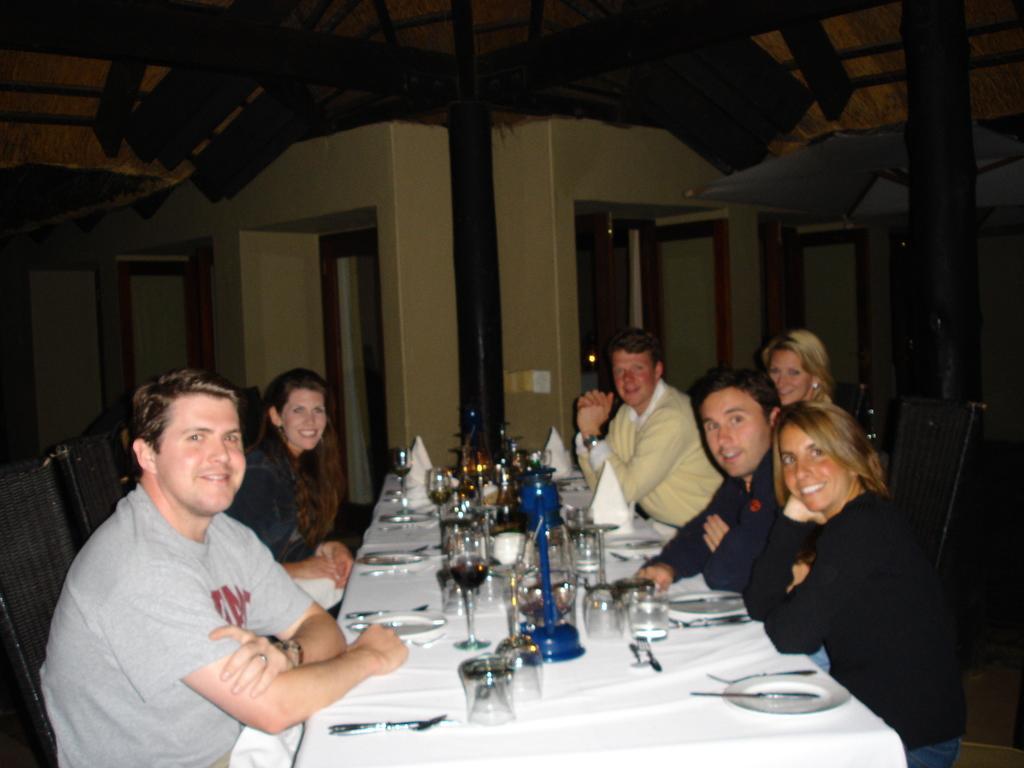Can you describe this image briefly? This image is taken in a room. Left side a person sitting beside to him there is a woman is sitting on the chair. At the right side there are four persons. In middle there is a table having glasses, lantern, plates ,forks napkins on the table. At the background there are doors open. 